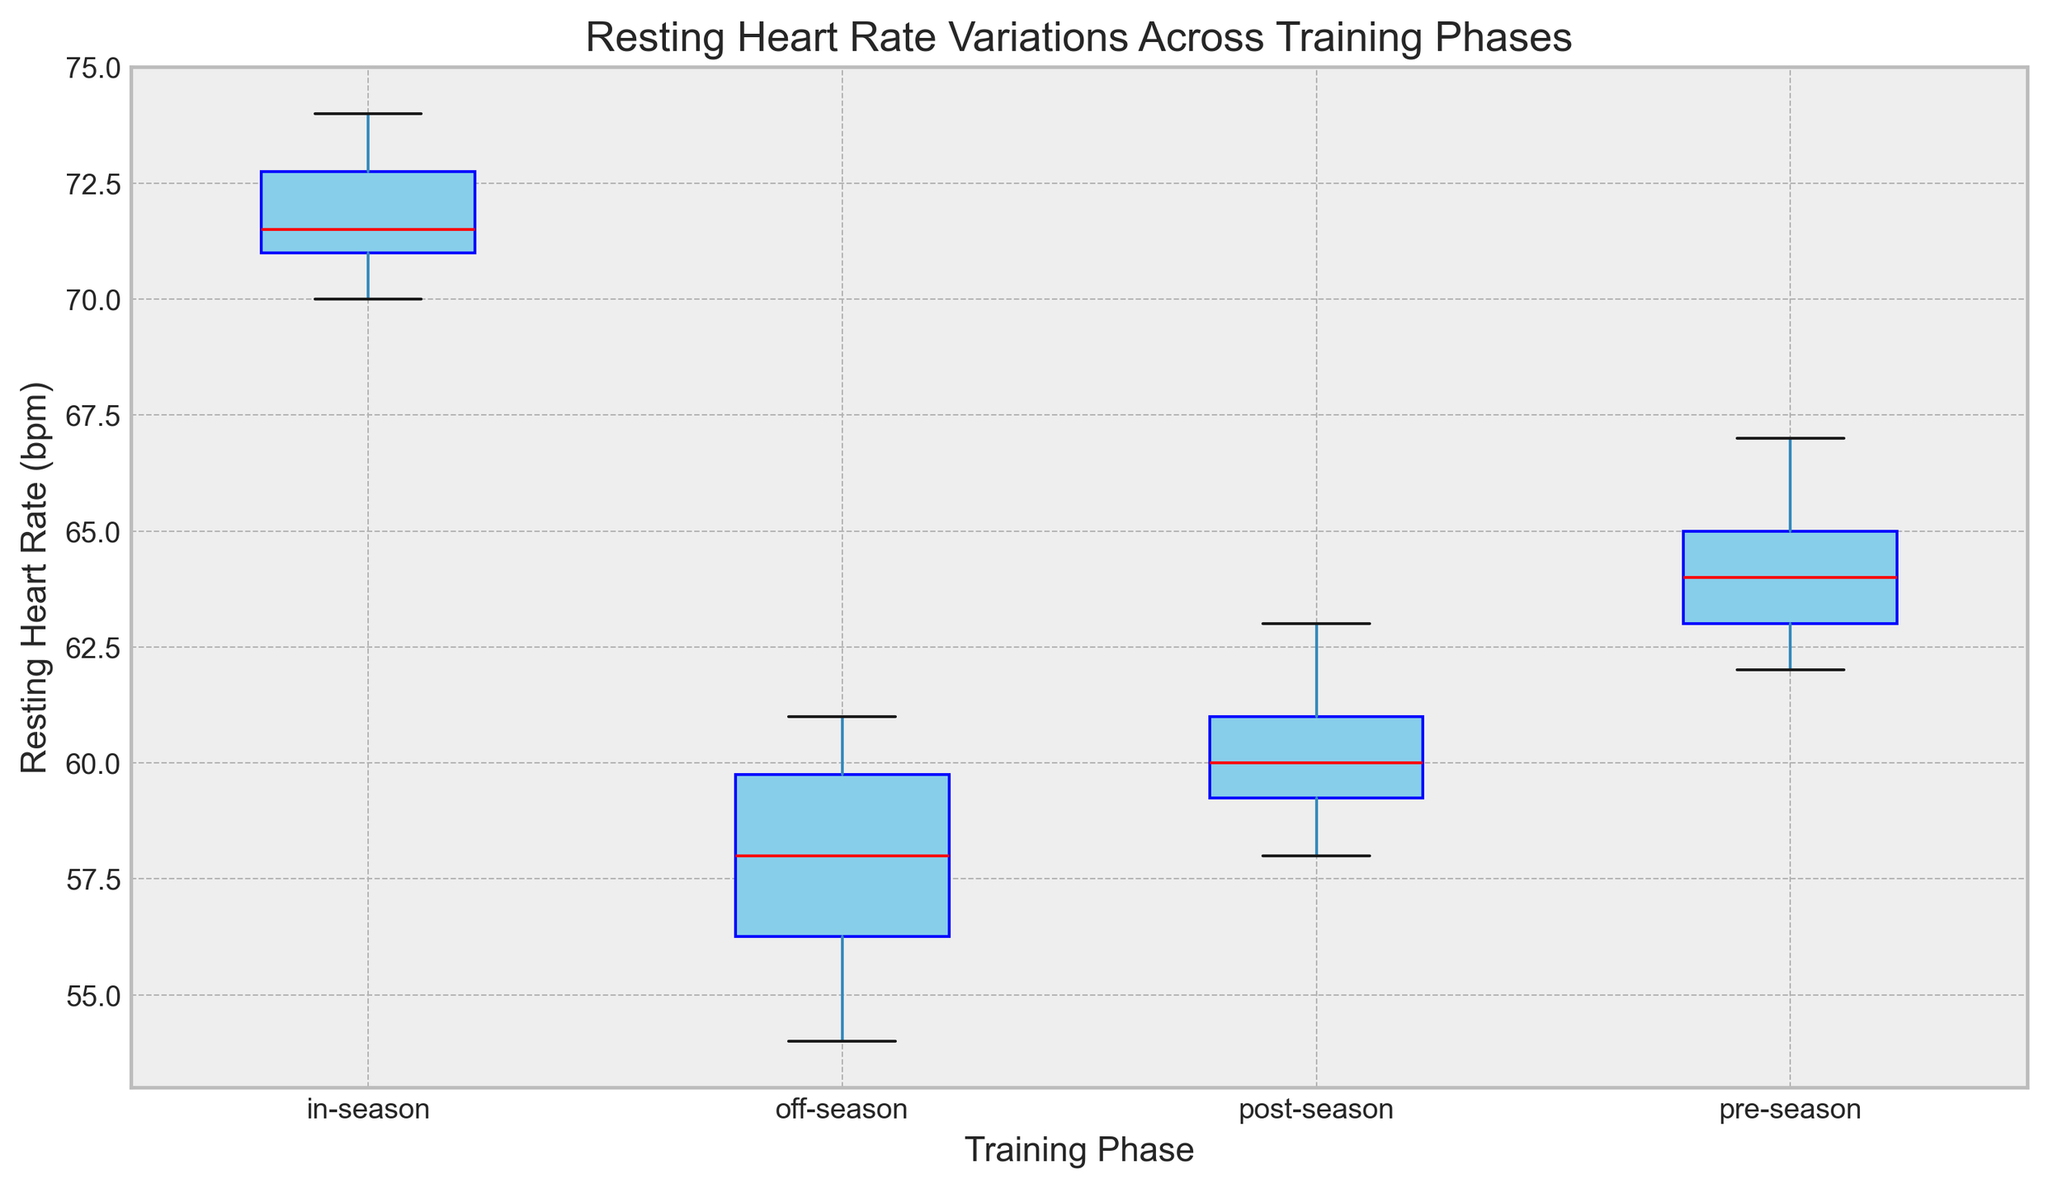Which training phase has the highest median resting heart rate? The median resting heart rate is marked by the red line within each box. By comparing the red lines, the in-season phase shows the highest median resting heart rate.
Answer: in-season What is the difference between the median resting heart rates of the off-season and pre-season phases? The red line indicates the median resting heart rate. The off-season median is around 58 bpm, and the pre-season median is around 64 bpm. Hence, the difference is 64 - 58.
Answer: 6 bpm Which training phase has the least variability in resting heart rate? Variability can be observed by the height of the boxes. The shorter the box, the less variability in the data. Among the phases, the post-season phase has the shortest box.
Answer: post-season Is the median resting heart rate of the post-season phase closer to the off-season or pre-season phase? The median resting heart rate of the post-season phase (around 60-61 bpm) is closer to the off-season (around 58 bpm) than the pre-season (around 64 bpm).
Answer: off-season Which training phase has the lowest maximum resting heart rate? Maximum resting heart rate is indicated by the top whisker of each box plot. The off-season phase has the lowest maximum resting heart rate, around 61 bpm.
Answer: off-season Which phase has outliers and how many are there? Outliers are depicted by dots outside the whiskers of the box plots. The in-season phase has outliers, specifically two dots above the top whisker.
Answer: in-season, 2 During which training phase does the resting heart rate fall into the widest range? The range is indicated by the distance between the bottom and top whiskers. The in-season phase has the widest range of resting heart rates.
Answer: in-season What is the approximate interquartile range (IQR) of the off-season phase? The IQR is the range between the first quartile (bottom of the box) and the third quartile (top of the box). For the off-season phase, the bottom of the box is around 56 bpm and the top is around 60 bpm. Therefore, the IQR is 60 - 56.
Answer: 4 bpm Which training phase generally shows an increased resting heart rate compared to other phases? Generally observing the median values (red lines): off-season < pre-season < in-season > post-season. The in-season phase has higher median values compared to other phases.
Answer: in-season Between which two consecutive phases is the increase in median resting heart rate the largest? By comparing the red lines, the largest increase in median resting heart rate is between the pre-season (around 64 bpm) and in-season (around 71 bpm).
Answer: pre-season and in-season 